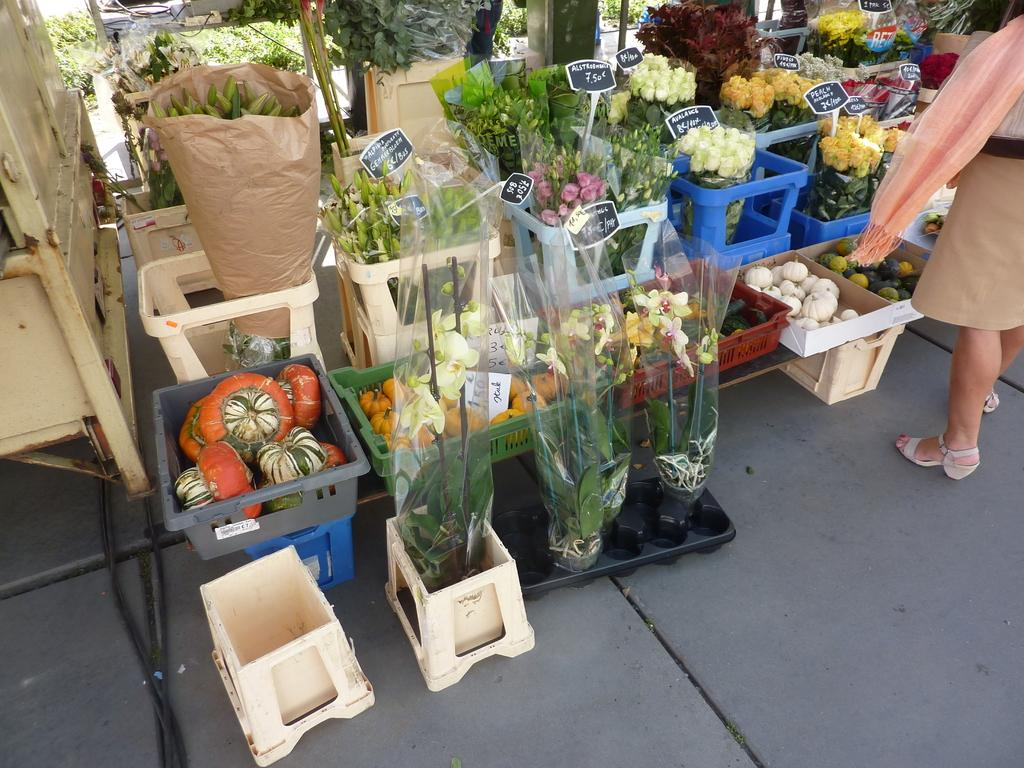What is located in the center of the image? There are flowers and vegetables in baskets in the center of the image. Can you describe the contents of the baskets? The baskets contain flowers and vegetables. Where is the lady positioned in the image? The lady is on the right side of the image. What type of fact can be seen in the image? There is no fact present in the image; it features flowers, vegetables, and a lady. What is the smell of the corn in the image? There is no corn present in the image, so it is not possible to determine its smell. 